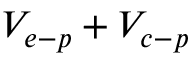Convert formula to latex. <formula><loc_0><loc_0><loc_500><loc_500>V _ { e - p } + V _ { c - p }</formula> 